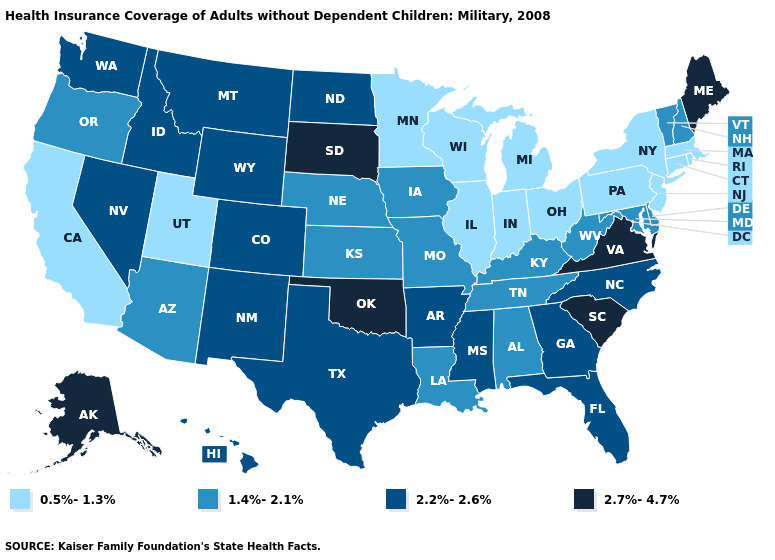What is the value of Delaware?
Give a very brief answer. 1.4%-2.1%. Does Indiana have the highest value in the USA?
Short answer required. No. Name the states that have a value in the range 1.4%-2.1%?
Answer briefly. Alabama, Arizona, Delaware, Iowa, Kansas, Kentucky, Louisiana, Maryland, Missouri, Nebraska, New Hampshire, Oregon, Tennessee, Vermont, West Virginia. Does Pennsylvania have the lowest value in the Northeast?
Quick response, please. Yes. What is the value of Kansas?
Short answer required. 1.4%-2.1%. What is the value of California?
Concise answer only. 0.5%-1.3%. Which states have the lowest value in the USA?
Short answer required. California, Connecticut, Illinois, Indiana, Massachusetts, Michigan, Minnesota, New Jersey, New York, Ohio, Pennsylvania, Rhode Island, Utah, Wisconsin. What is the lowest value in the USA?
Give a very brief answer. 0.5%-1.3%. What is the highest value in the USA?
Keep it brief. 2.7%-4.7%. Which states hav the highest value in the West?
Be succinct. Alaska. Name the states that have a value in the range 0.5%-1.3%?
Short answer required. California, Connecticut, Illinois, Indiana, Massachusetts, Michigan, Minnesota, New Jersey, New York, Ohio, Pennsylvania, Rhode Island, Utah, Wisconsin. Which states hav the highest value in the South?
Give a very brief answer. Oklahoma, South Carolina, Virginia. What is the lowest value in the MidWest?
Short answer required. 0.5%-1.3%. Which states have the highest value in the USA?
Write a very short answer. Alaska, Maine, Oklahoma, South Carolina, South Dakota, Virginia. Name the states that have a value in the range 1.4%-2.1%?
Be succinct. Alabama, Arizona, Delaware, Iowa, Kansas, Kentucky, Louisiana, Maryland, Missouri, Nebraska, New Hampshire, Oregon, Tennessee, Vermont, West Virginia. 